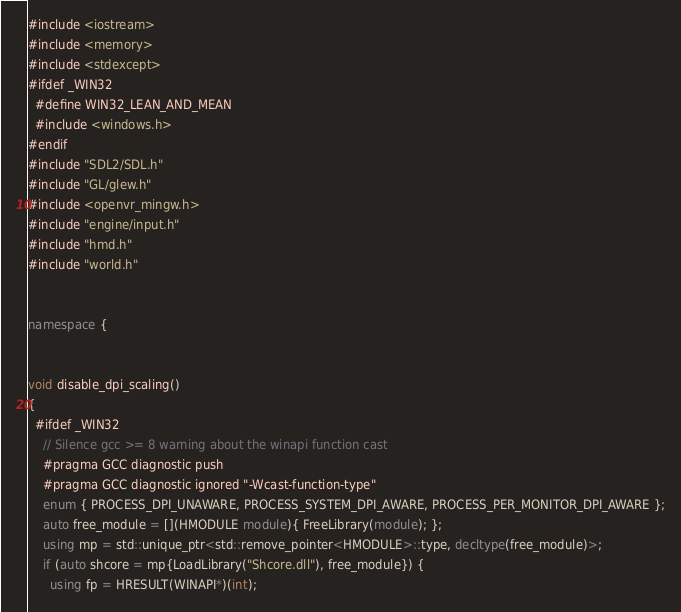<code> <loc_0><loc_0><loc_500><loc_500><_C++_>#include <iostream>
#include <memory>
#include <stdexcept>
#ifdef _WIN32
  #define WIN32_LEAN_AND_MEAN
  #include <windows.h>
#endif
#include "SDL2/SDL.h"
#include "GL/glew.h"
#include <openvr_mingw.h>
#include "engine/input.h"
#include "hmd.h"
#include "world.h"


namespace {


void disable_dpi_scaling()
{
  #ifdef _WIN32
    // Silence gcc >= 8 warning about the winapi function cast
    #pragma GCC diagnostic push
    #pragma GCC diagnostic ignored "-Wcast-function-type"
    enum { PROCESS_DPI_UNAWARE, PROCESS_SYSTEM_DPI_AWARE, PROCESS_PER_MONITOR_DPI_AWARE };
    auto free_module = [](HMODULE module){ FreeLibrary(module); };
    using mp = std::unique_ptr<std::remove_pointer<HMODULE>::type, decltype(free_module)>;
    if (auto shcore = mp{LoadLibrary("Shcore.dll"), free_module}) {
      using fp = HRESULT(WINAPI*)(int);</code> 